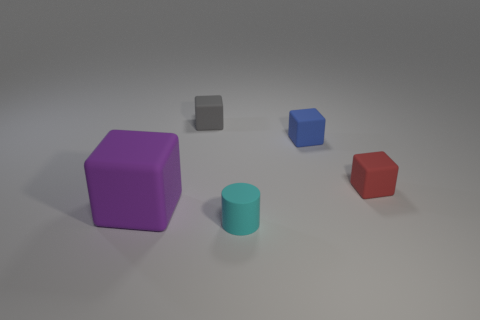Subtract 1 blocks. How many blocks are left? 3 Subtract all brown cubes. Subtract all gray spheres. How many cubes are left? 4 Add 1 purple rubber cubes. How many objects exist? 6 Subtract all cubes. How many objects are left? 1 Add 2 gray blocks. How many gray blocks exist? 3 Subtract 0 green cylinders. How many objects are left? 5 Subtract all cylinders. Subtract all green cylinders. How many objects are left? 4 Add 3 large purple objects. How many large purple objects are left? 4 